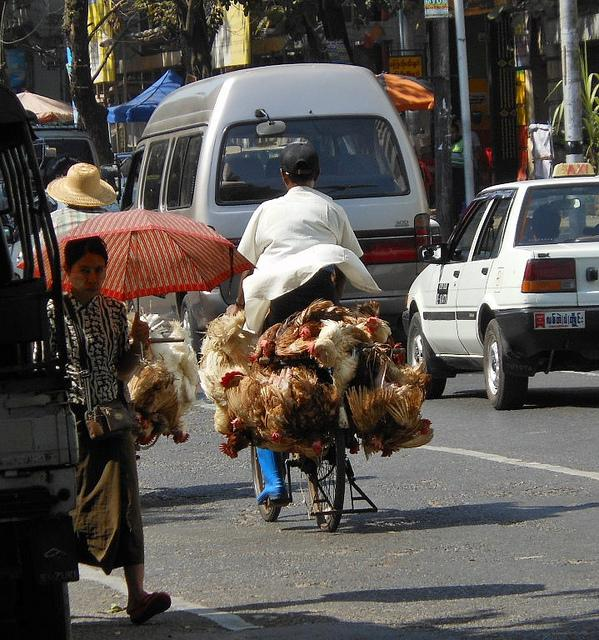What does the man on the bike do for a living? Please explain your reasoning. sells chickens. The man has chickens on the bike. 